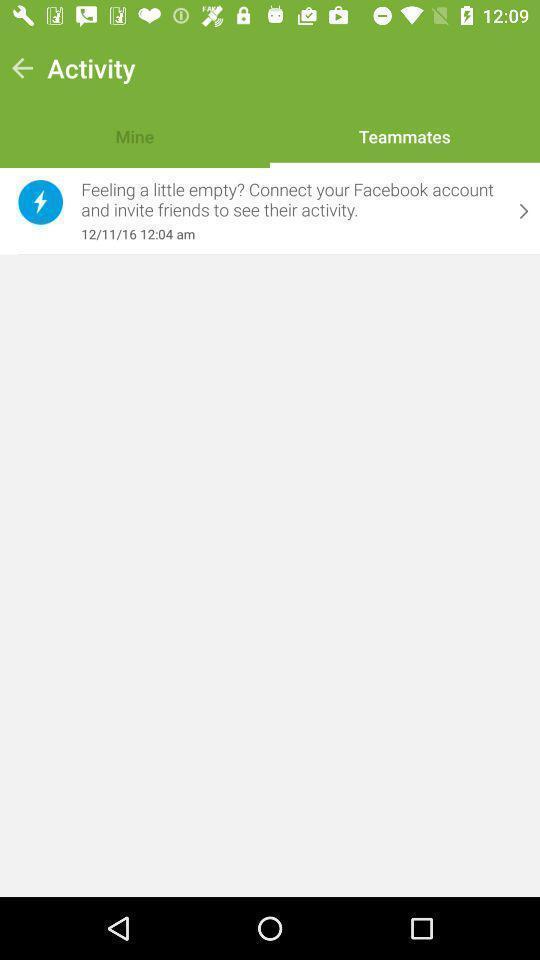What details can you identify in this image? Screen page displaying an information with other options. 